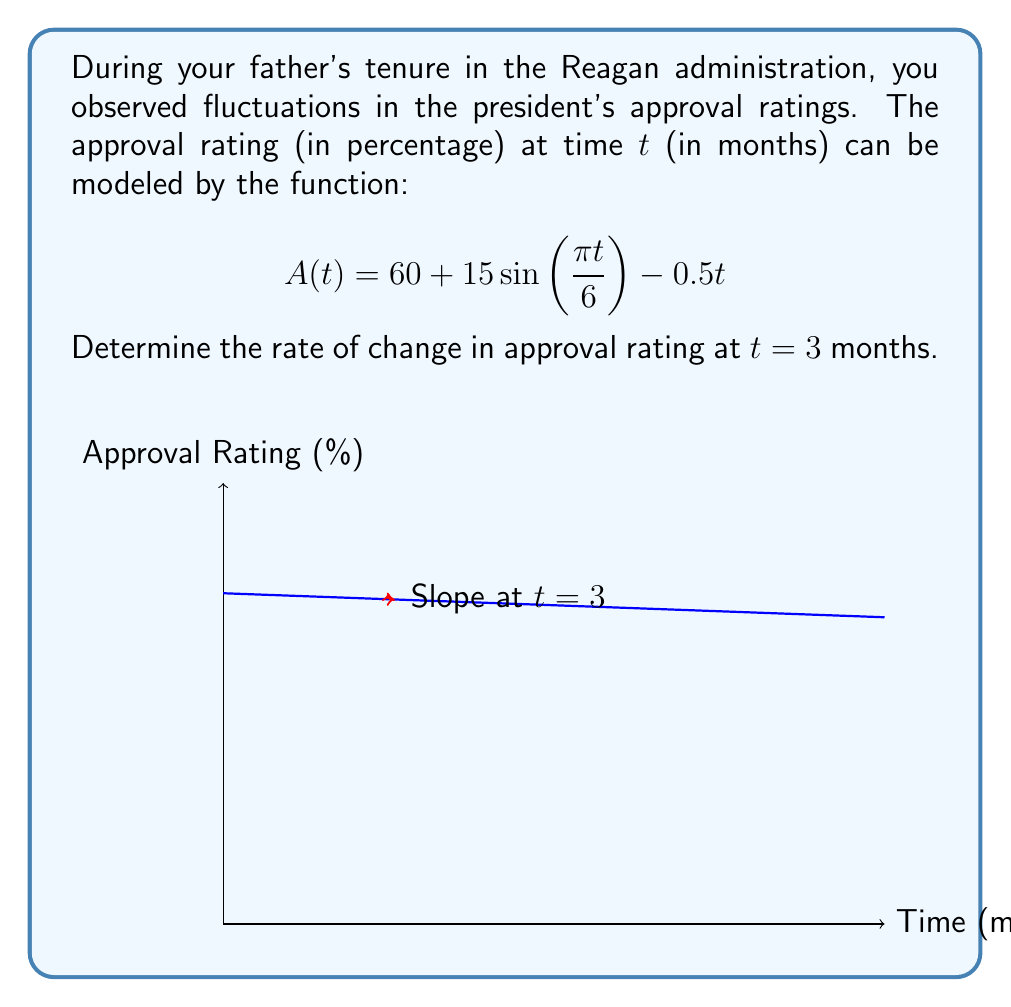What is the answer to this math problem? To find the rate of change at $t = 3$, we need to calculate the derivative of $A(t)$ and evaluate it at $t = 3$.

1) First, let's find $A'(t)$ using the chain rule and power rule:

   $$A'(t) = 15 \cdot \frac{\pi}{6} \cos(\frac{\pi t}{6}) - 0.5$$

2) Now, we evaluate $A'(3)$:

   $$A'(3) = 15 \cdot \frac{\pi}{6} \cos(\frac{\pi \cdot 3}{6}) - 0.5$$

3) Simplify:
   
   $$A'(3) = \frac{15\pi}{6} \cos(\frac{\pi}{2}) - 0.5$$

4) Recall that $\cos(\frac{\pi}{2}) = 0$:

   $$A'(3) = \frac{15\pi}{6} \cdot 0 - 0.5 = -0.5$$

The negative value indicates that the approval rating is decreasing at $t = 3$ months.
Answer: $-0.5$ percentage points per month 